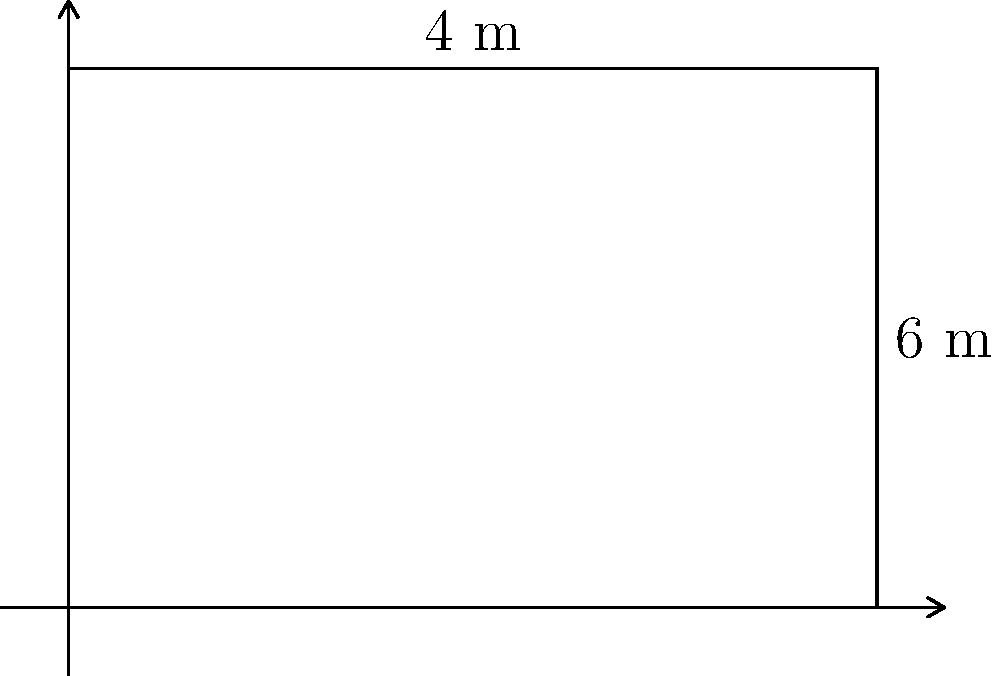You need to calculate the floor area of a rectangular tent in the refugee camp. The tent's length is 6 meters and its width is 4 meters. What is the total area of the tent floor in square meters? To find the area of a rectangular tent floor, we need to multiply its length by its width.

Given:
- Length of the tent = 6 meters
- Width of the tent = 4 meters

Step 1: Use the formula for the area of a rectangle.
Area = Length × Width

Step 2: Substitute the known values into the formula.
Area = 6 m × 4 m

Step 3: Perform the multiplication.
Area = 24 m²

Therefore, the total area of the tent floor is 24 square meters.
Answer: 24 m² 